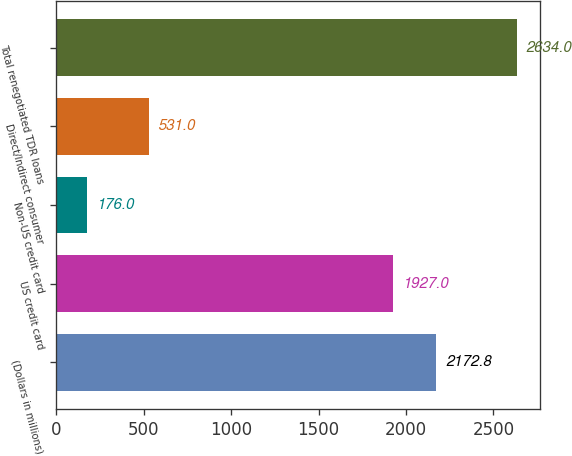Convert chart to OTSL. <chart><loc_0><loc_0><loc_500><loc_500><bar_chart><fcel>(Dollars in millions)<fcel>US credit card<fcel>Non-US credit card<fcel>Direct/Indirect consumer<fcel>Total renegotiated TDR loans<nl><fcel>2172.8<fcel>1927<fcel>176<fcel>531<fcel>2634<nl></chart> 